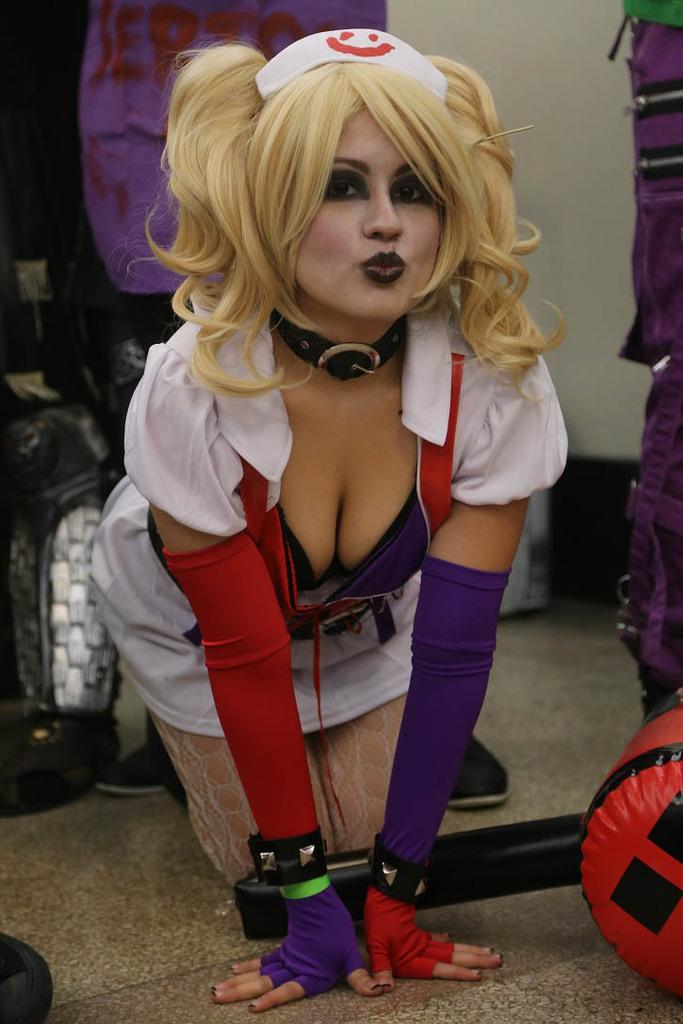Who is present in the image? There is a woman in the image. What is on the floor in the image? There are objects on the floor in the image. What can be seen in the background of the image? There is a wall and additional things visible in the background of the image. What type of skate is being used to destroy the wall in the image? There is no skate or destruction present in the image. Who is the coach in the image? There is no coach present in the image. 